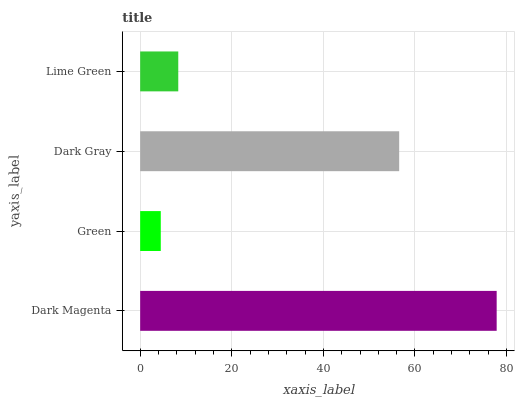Is Green the minimum?
Answer yes or no. Yes. Is Dark Magenta the maximum?
Answer yes or no. Yes. Is Dark Gray the minimum?
Answer yes or no. No. Is Dark Gray the maximum?
Answer yes or no. No. Is Dark Gray greater than Green?
Answer yes or no. Yes. Is Green less than Dark Gray?
Answer yes or no. Yes. Is Green greater than Dark Gray?
Answer yes or no. No. Is Dark Gray less than Green?
Answer yes or no. No. Is Dark Gray the high median?
Answer yes or no. Yes. Is Lime Green the low median?
Answer yes or no. Yes. Is Dark Magenta the high median?
Answer yes or no. No. Is Dark Magenta the low median?
Answer yes or no. No. 